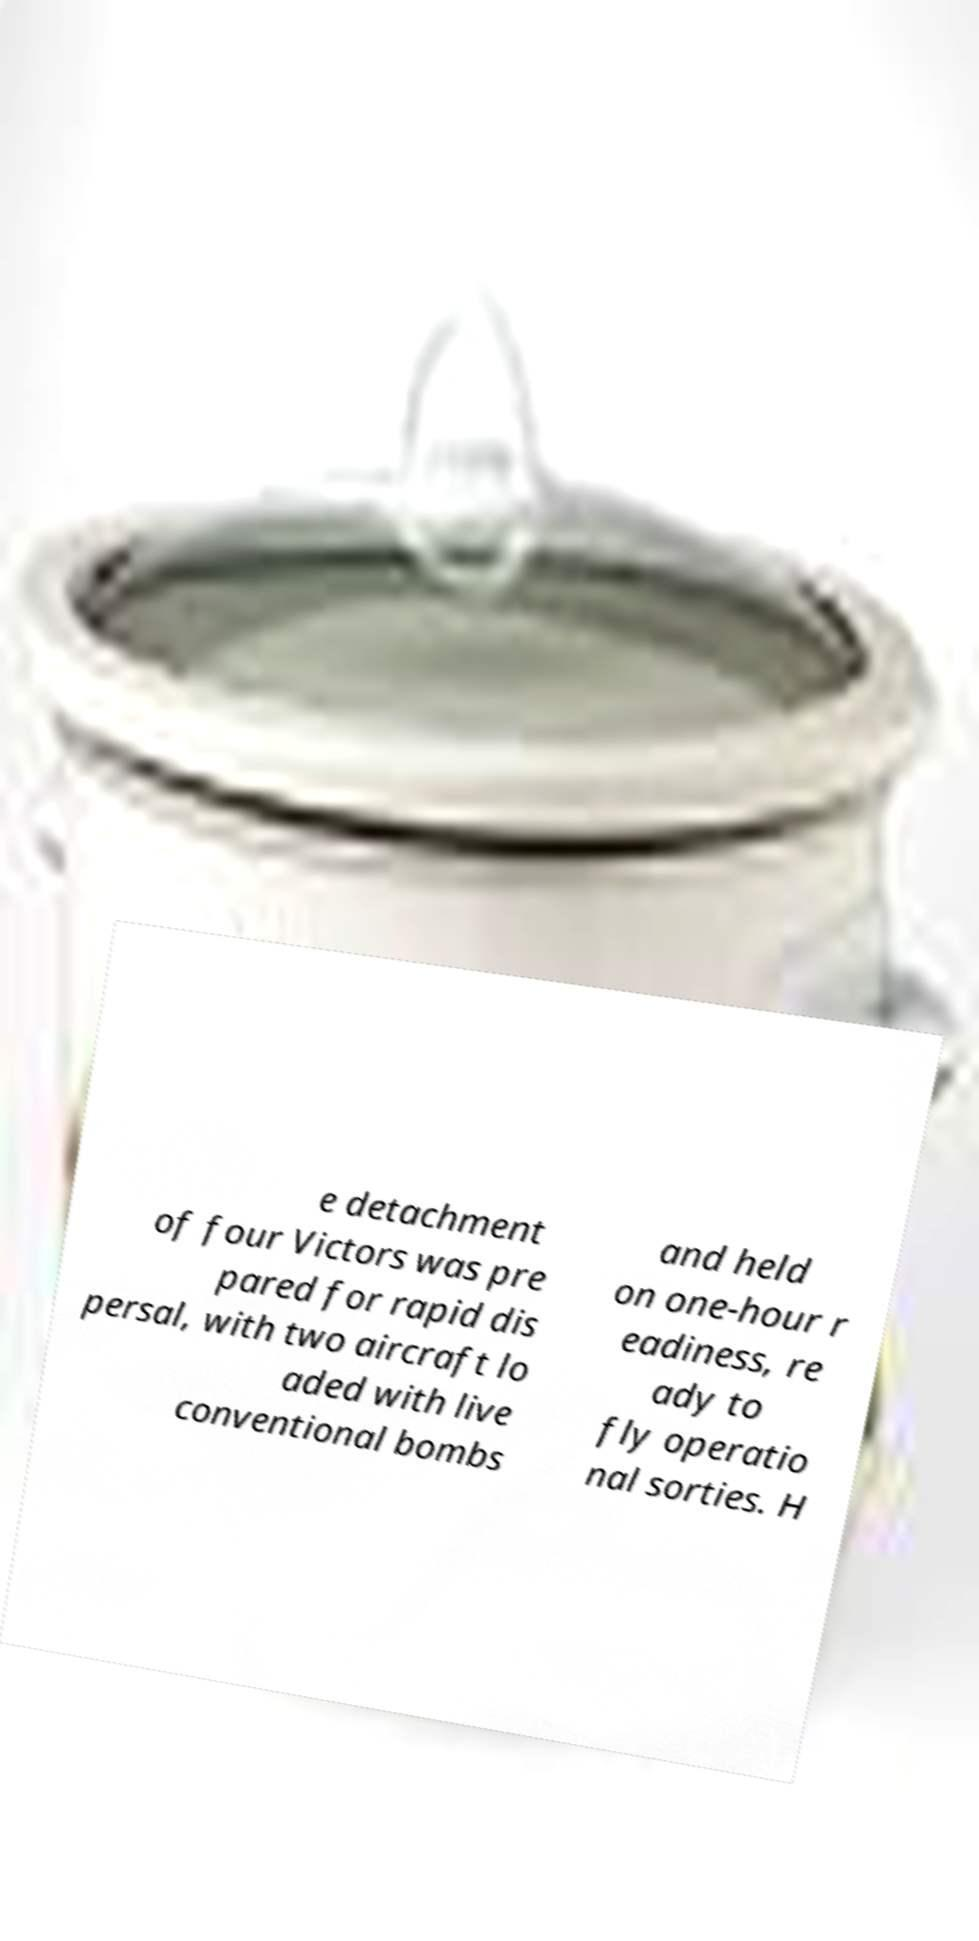What messages or text are displayed in this image? I need them in a readable, typed format. e detachment of four Victors was pre pared for rapid dis persal, with two aircraft lo aded with live conventional bombs and held on one-hour r eadiness, re ady to fly operatio nal sorties. H 